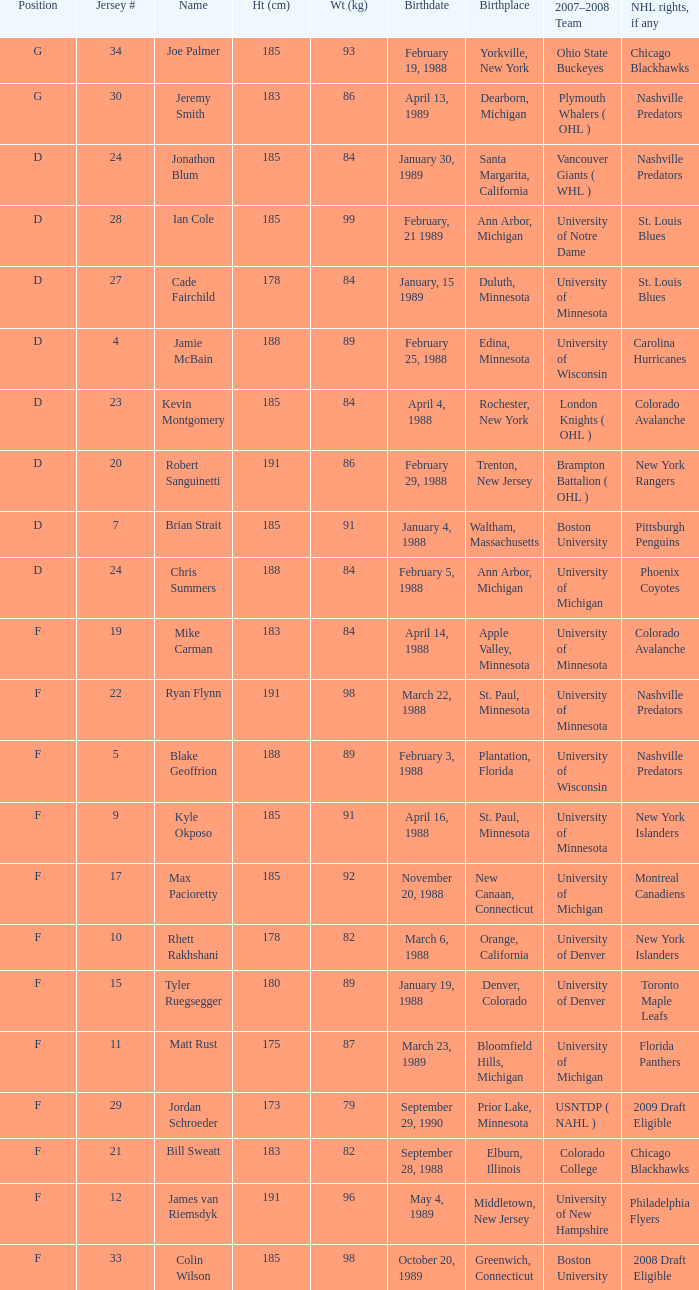Which Height (cm) has a Birthplace of bloomfield hills, michigan? 175.0. 